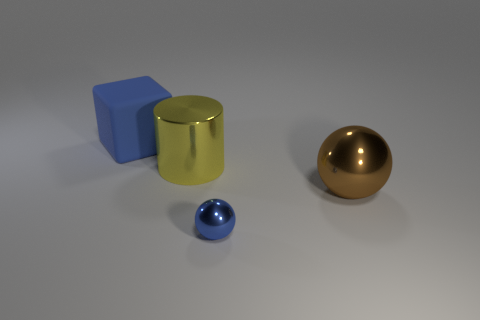Are there any other things that have the same size as the blue metal ball?
Keep it short and to the point. No. Are there any other things that are the same material as the blue block?
Your response must be concise. No. There is a blue thing that is in front of the brown thing; is there a big yellow shiny cylinder in front of it?
Your answer should be very brief. No. How many tiny shiny things are there?
Provide a succinct answer. 1. The thing that is behind the brown ball and in front of the blue cube is what color?
Offer a terse response. Yellow. There is a brown thing that is the same shape as the small blue thing; what is its size?
Your answer should be compact. Large. How many brown spheres have the same size as the blue block?
Make the answer very short. 1. What is the material of the big block?
Your answer should be compact. Rubber. Are there any yellow objects in front of the shiny cylinder?
Your answer should be very brief. No. There is a brown sphere that is the same material as the large cylinder; what is its size?
Give a very brief answer. Large. 